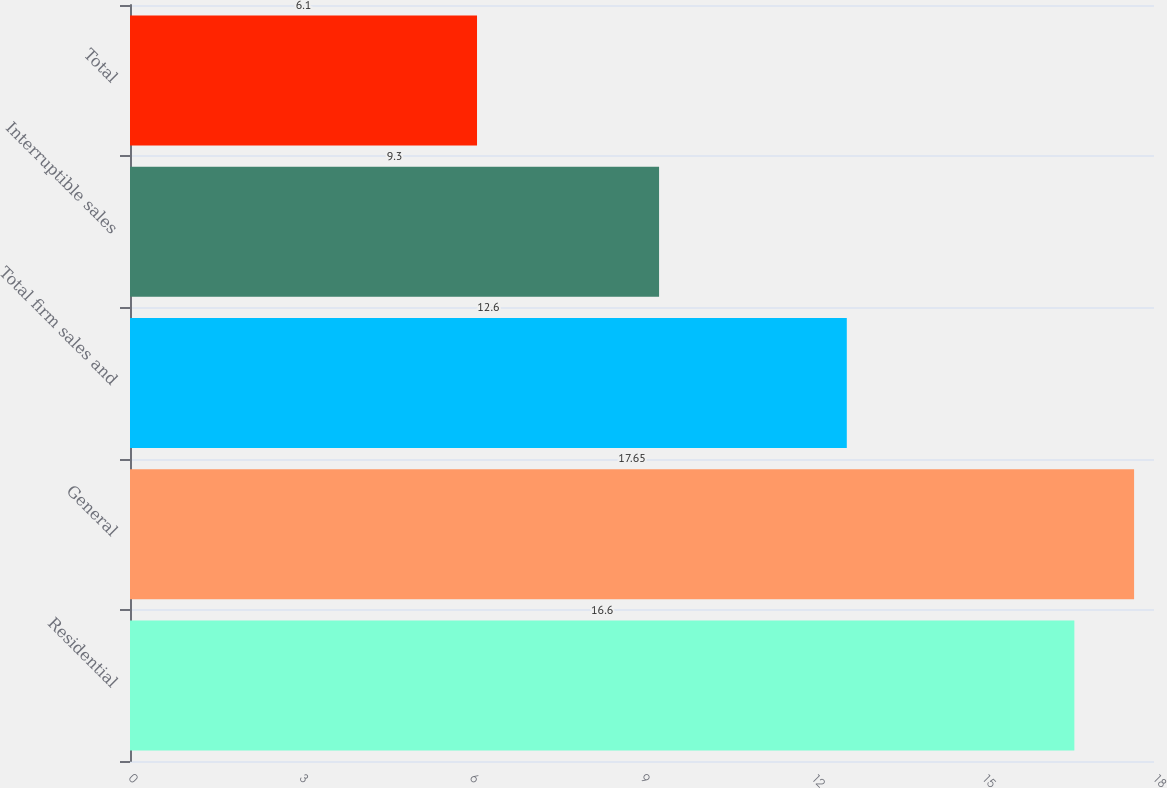<chart> <loc_0><loc_0><loc_500><loc_500><bar_chart><fcel>Residential<fcel>General<fcel>Total firm sales and<fcel>Interruptible sales<fcel>Total<nl><fcel>16.6<fcel>17.65<fcel>12.6<fcel>9.3<fcel>6.1<nl></chart> 